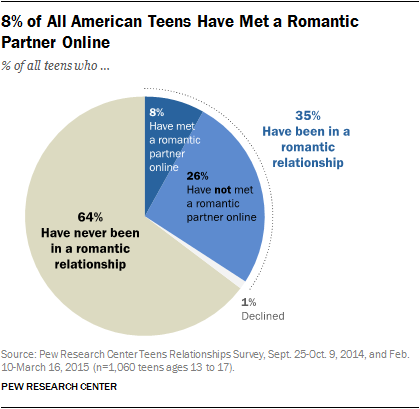Indicate a few pertinent items in this graphic. The ratio of the smallest and largest segments is approximately 0.015625, which is a very small ratio when compared to the size of the entire range. According to a study, 64% of all teenagers have never been in a romantic relationship. 